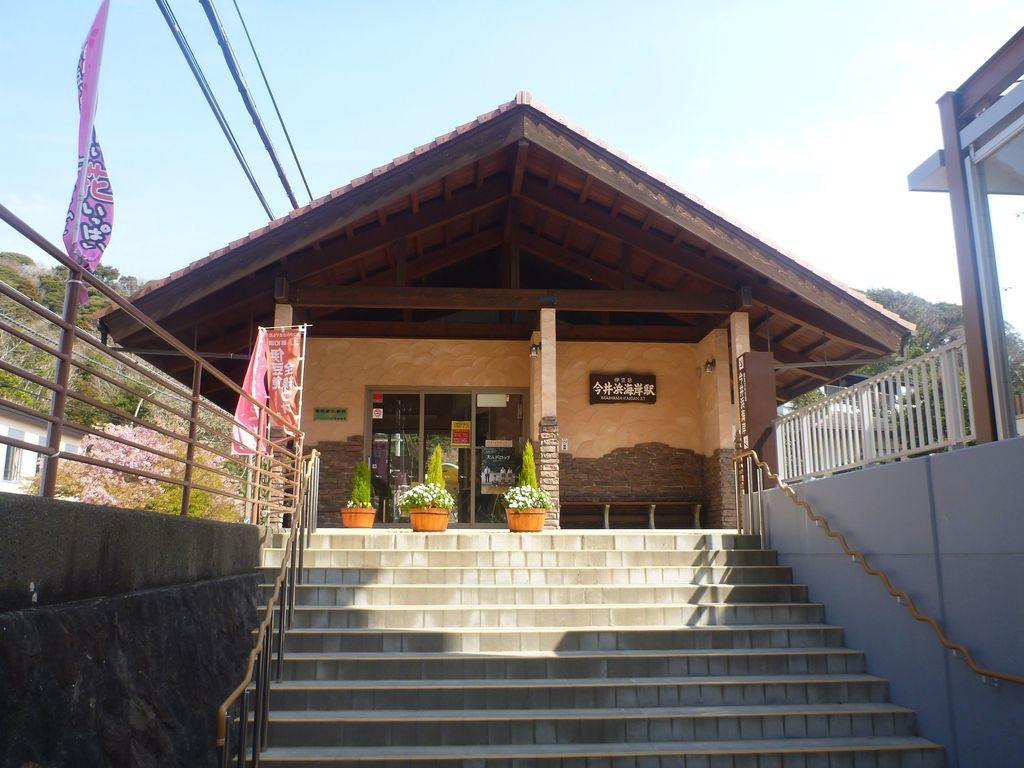What is the main structure in the center of the image? There is a house in the center of the image. What can be seen at the bottom side of the image? There are stairs at the bottom side of the image. What is present on the right side of the image? There is a boundary on the right side of the image. What is present on the left side of the image? There is a boundary on the left side of the image. What type of oil is being used to maintain the boundaries in the image? There is no mention of oil or any maintenance activity in the image; the boundaries are simply present. 